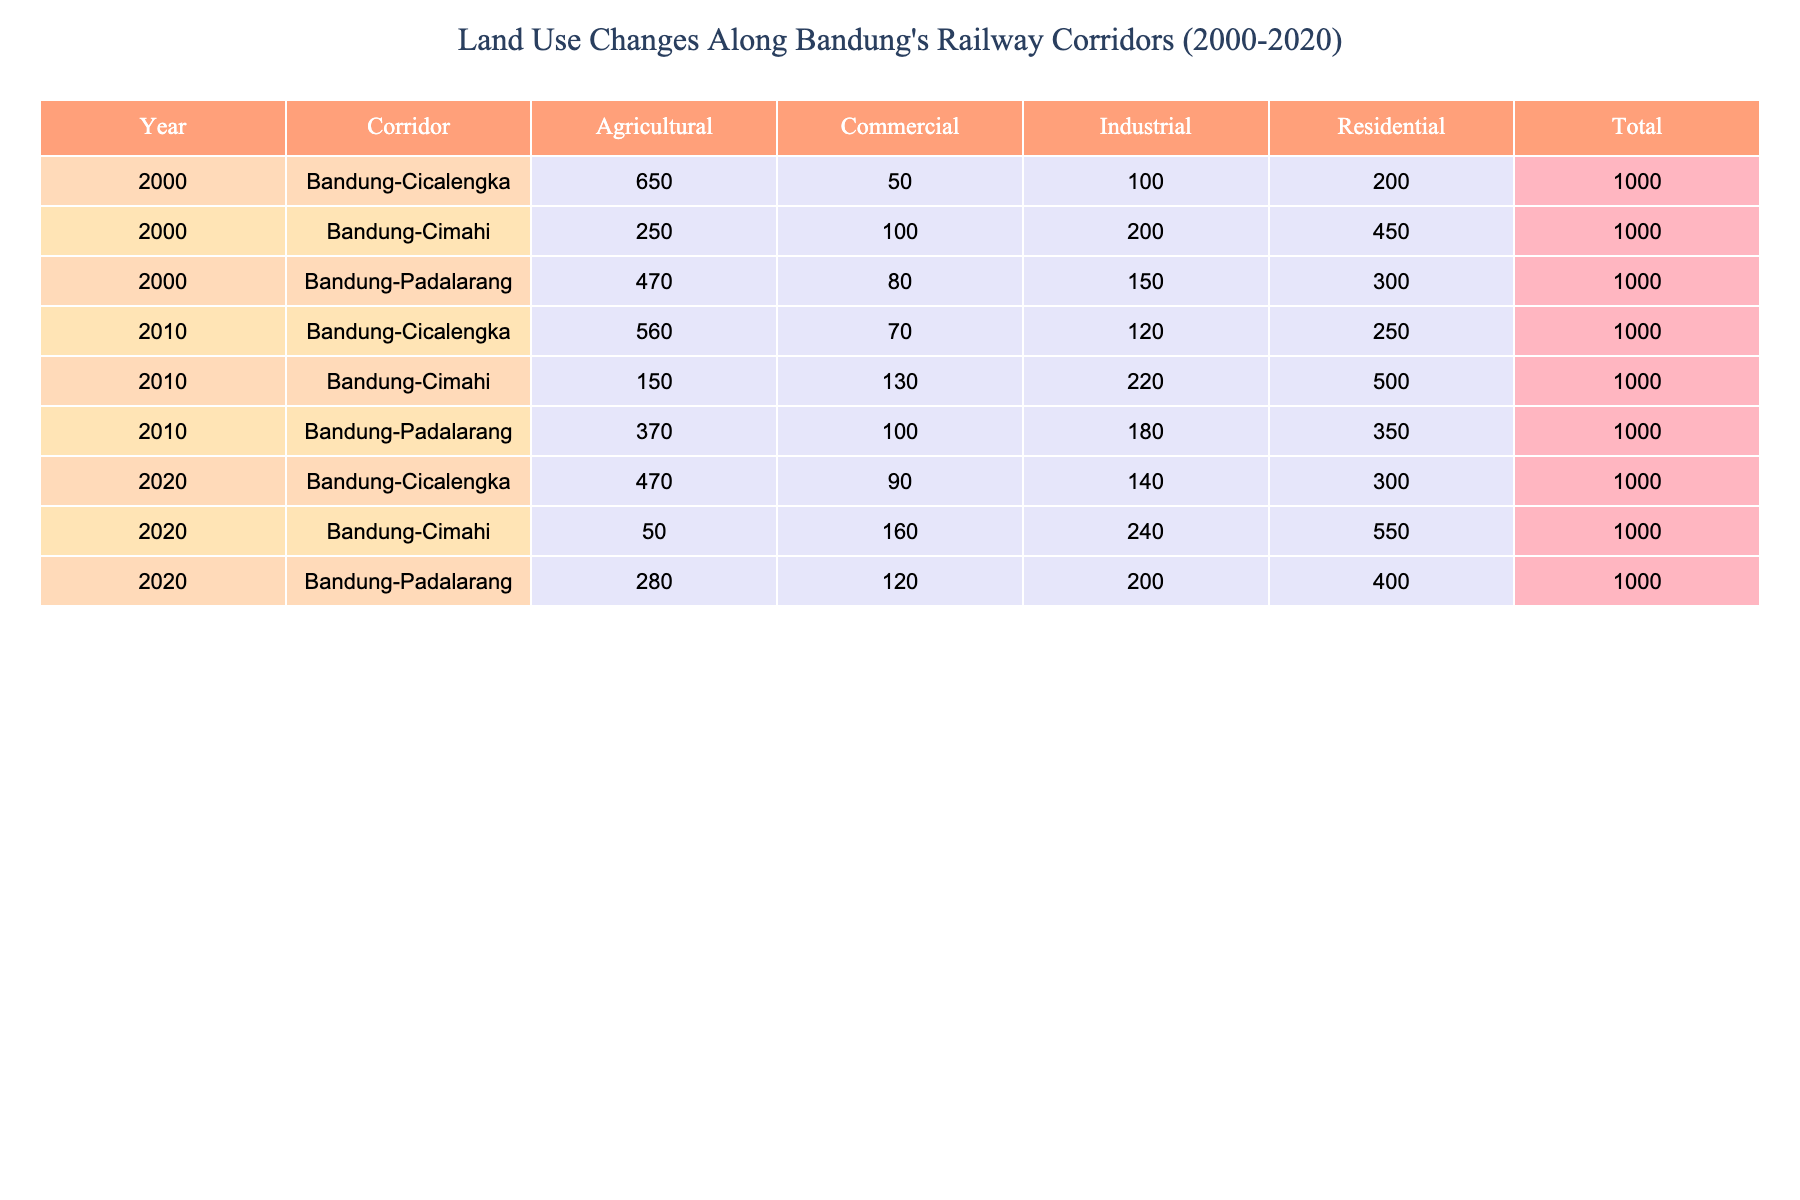What is the total area of agricultural land in Bandung-Cimahi corridor in 2020? In 2020, the area of agricultural land in the Bandung-Cimahi corridor is recorded as 50 hectares.
Answer: 50 How much industrial land was there in Bandung-Padalarang corridor in 2010? In 2010, the area of industrial land in the Bandung-Padalarang corridor is noted as 180 hectares.
Answer: 180 Which corridor had the highest population density in 2000? In the table, the Bandung-Cimahi corridor had the highest population density in 2000 at 12,000 people/km2.
Answer: Bandung-Cimahi What's the change in total area for residential land from 2000 to 2020 in the Bandung-Cicalengka corridor? For Bandung-Cicalengka, in 2000 there were 200 hectares of residential land and in 2020 there were 300 hectares. The change is 300 - 200 = 100 hectares.
Answer: 100 Was there a decrease in agricultural land in the Bandung-Cimahi corridor from 2000 to 2020? Yes, in 2000 there were 250 hectares of agricultural land and in 2020, it decreased to 50 hectares, indicating a decrease of 200 hectares.
Answer: Yes What is the average economic activity score for industrial land across all corridors in 2010? The industrial economic activity scores for the three corridors in 2010 are 8, 8, and 7. Adding them gives 8 + 8 + 7 = 23. The average is 23 / 3 = 7.67.
Answer: 7.67 By how much did the area of commercial land change in the Bandung-Padalarang corridor from 2010 to 2020? In 2010, there were 100 hectares of commercial land in Bandung-Padalarang, which increased to 120 hectares in 2020. The change is 120 - 100 = 20 hectares.
Answer: 20 What percentage of the total area in the Bandung-Cimahi corridor was used for residential purposes in 2020? In 2020, the total area for the Bandung-Cimahi corridor was 550 (residential) + 240 (industrial) + 160 (commercial) + 50 (agricultural) = 1000 hectares. The residential area is 550 hectares, so the percentage is (550 / 1000) * 100 = 55%.
Answer: 55% 